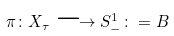<formula> <loc_0><loc_0><loc_500><loc_500>\pi \colon X _ { \tau } \longrightarrow S _ { - } ^ { 1 } \colon = B</formula> 